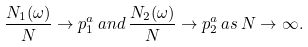Convert formula to latex. <formula><loc_0><loc_0><loc_500><loc_500>\frac { N _ { 1 } ( \omega ) } { N } \to p _ { 1 } ^ { a } \, a n d \, \frac { N _ { 2 } ( \omega ) } { N } \to p _ { 2 } ^ { a } \, a s \, N \to \infty .</formula> 